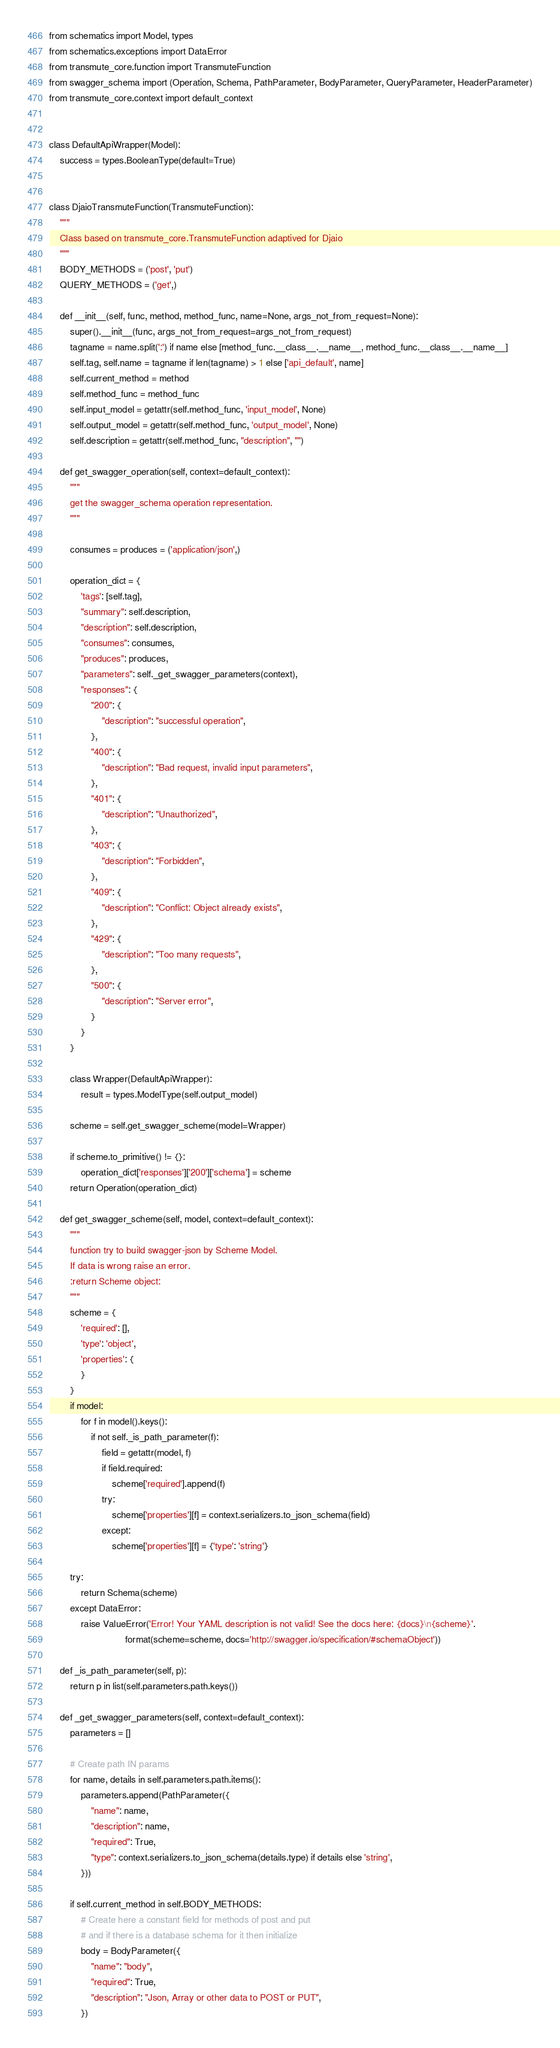Convert code to text. <code><loc_0><loc_0><loc_500><loc_500><_Python_>from schematics import Model, types
from schematics.exceptions import DataError
from transmute_core.function import TransmuteFunction
from swagger_schema import (Operation, Schema, PathParameter, BodyParameter, QueryParameter, HeaderParameter)
from transmute_core.context import default_context


class DefaultApiWrapper(Model):
    success = types.BooleanType(default=True)


class DjaioTransmuteFunction(TransmuteFunction):
    """
    Class based on transmute_core.TransmuteFunction adaptived for Djaio
    """
    BODY_METHODS = ('post', 'put')
    QUERY_METHODS = ('get',)

    def __init__(self, func, method, method_func, name=None, args_not_from_request=None):
        super().__init__(func, args_not_from_request=args_not_from_request)
        tagname = name.split(':') if name else [method_func.__class__.__name__, method_func.__class__.__name__]
        self.tag, self.name = tagname if len(tagname) > 1 else ['api_default', name]
        self.current_method = method
        self.method_func = method_func
        self.input_model = getattr(self.method_func, 'input_model', None)
        self.output_model = getattr(self.method_func, 'output_model', None)
        self.description = getattr(self.method_func, "description", "")

    def get_swagger_operation(self, context=default_context):
        """
        get the swagger_schema operation representation.
        """

        consumes = produces = ('application/json',)

        operation_dict = {
            'tags': [self.tag],
            "summary": self.description,
            "description": self.description,
            "consumes": consumes,
            "produces": produces,
            "parameters": self._get_swagger_parameters(context),
            "responses": {
                "200": {
                    "description": "successful operation",
                },
                "400": {
                    "description": "Bad request, invalid input parameters",
                },
                "401": {
                    "description": "Unauthorized",
                },
                "403": {
                    "description": "Forbidden",
                },
                "409": {
                    "description": "Conflict: Object already exists",
                },
                "429": {
                    "description": "Too many requests",
                },
                "500": {
                    "description": "Server error",
                }
            }
        }

        class Wrapper(DefaultApiWrapper):
            result = types.ModelType(self.output_model)

        scheme = self.get_swagger_scheme(model=Wrapper)

        if scheme.to_primitive() != {}:
            operation_dict['responses']['200']['schema'] = scheme
        return Operation(operation_dict)

    def get_swagger_scheme(self, model, context=default_context):
        """
        function try to build swagger-json by Scheme Model.
        If data is wrong raise an error.
        :return Scheme object:
        """
        scheme = {
            'required': [],
            'type': 'object',
            'properties': {
            }
        }
        if model:
            for f in model().keys():
                if not self._is_path_parameter(f):
                    field = getattr(model, f)
                    if field.required:
                        scheme['required'].append(f)
                    try:
                        scheme['properties'][f] = context.serializers.to_json_schema(field)
                    except:
                        scheme['properties'][f] = {'type': 'string'}

        try:
            return Schema(scheme)
        except DataError:
            raise ValueError('Error! Your YAML description is not valid! See the docs here: {docs}\n{scheme}'.
                             format(scheme=scheme, docs='http://swagger.io/specification/#schemaObject'))

    def _is_path_parameter(self, p):
        return p in list(self.parameters.path.keys())

    def _get_swagger_parameters(self, context=default_context):
        parameters = []

        # Create path IN params
        for name, details in self.parameters.path.items():
            parameters.append(PathParameter({
                "name": name,
                "description": name,
                "required": True,
                "type": context.serializers.to_json_schema(details.type) if details else 'string',
            }))

        if self.current_method in self.BODY_METHODS:
            # Create here a constant field for methods of post and put
            # and if there is a database schema for it then initialize
            body = BodyParameter({
                "name": "body",
                "required": True,
                "description": "Json, Array or other data to POST or PUT",
            })</code> 